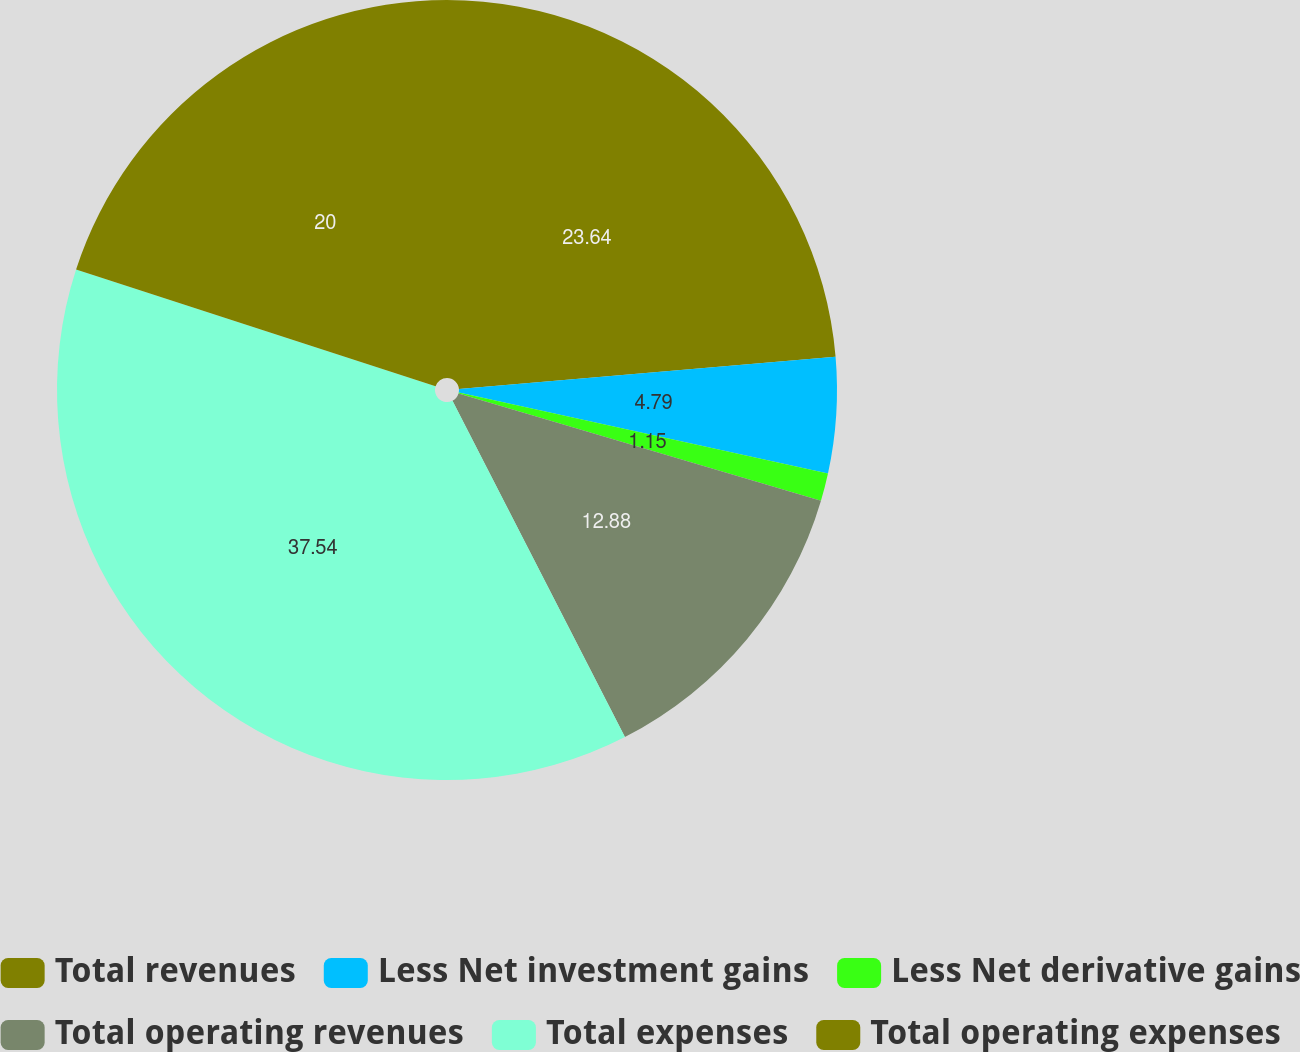<chart> <loc_0><loc_0><loc_500><loc_500><pie_chart><fcel>Total revenues<fcel>Less Net investment gains<fcel>Less Net derivative gains<fcel>Total operating revenues<fcel>Total expenses<fcel>Total operating expenses<nl><fcel>23.64%<fcel>4.79%<fcel>1.15%<fcel>12.88%<fcel>37.54%<fcel>20.0%<nl></chart> 